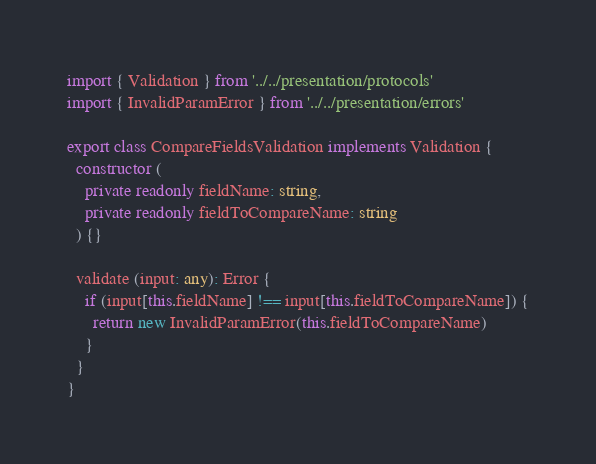Convert code to text. <code><loc_0><loc_0><loc_500><loc_500><_TypeScript_>import { Validation } from '../../presentation/protocols'
import { InvalidParamError } from '../../presentation/errors'

export class CompareFieldsValidation implements Validation {
  constructor (
    private readonly fieldName: string,
    private readonly fieldToCompareName: string
  ) {}

  validate (input: any): Error {
    if (input[this.fieldName] !== input[this.fieldToCompareName]) {
      return new InvalidParamError(this.fieldToCompareName)
    }
  }
}
</code> 